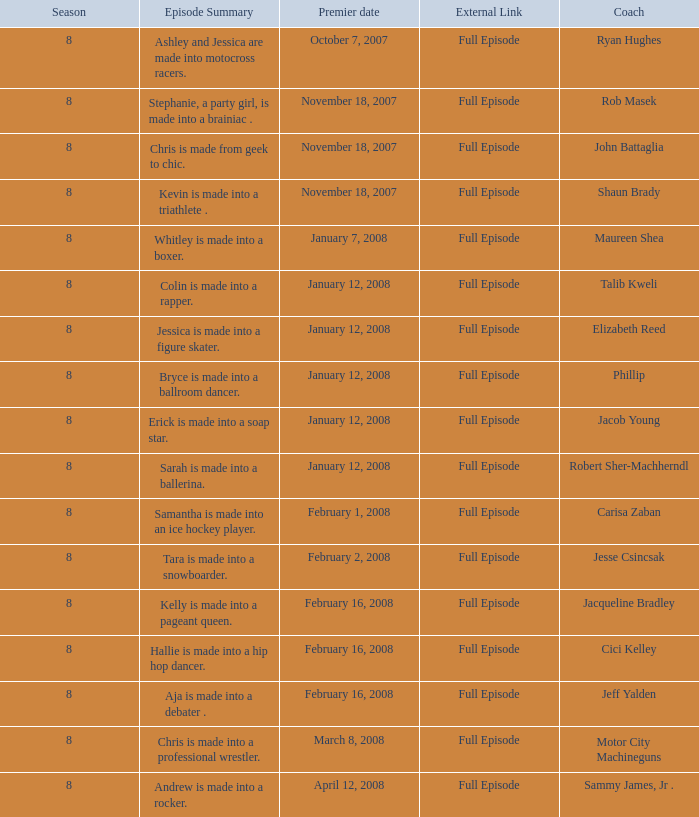Which trainer debuted on february 16, 2008, following episode 2 Jeff Yalden. 